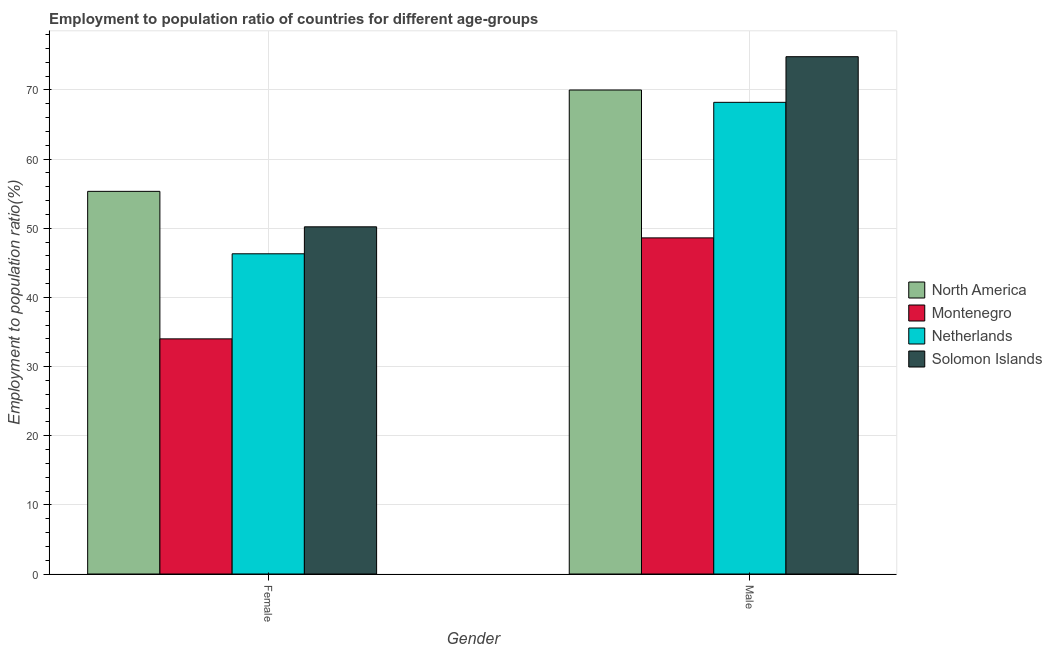How many groups of bars are there?
Your response must be concise. 2. Are the number of bars per tick equal to the number of legend labels?
Offer a very short reply. Yes. Are the number of bars on each tick of the X-axis equal?
Your response must be concise. Yes. How many bars are there on the 1st tick from the right?
Offer a very short reply. 4. What is the label of the 1st group of bars from the left?
Your response must be concise. Female. What is the employment to population ratio(female) in Netherlands?
Keep it short and to the point. 46.3. Across all countries, what is the maximum employment to population ratio(male)?
Offer a very short reply. 74.8. Across all countries, what is the minimum employment to population ratio(male)?
Your answer should be very brief. 48.6. In which country was the employment to population ratio(female) maximum?
Give a very brief answer. North America. In which country was the employment to population ratio(male) minimum?
Make the answer very short. Montenegro. What is the total employment to population ratio(female) in the graph?
Provide a short and direct response. 185.83. What is the difference between the employment to population ratio(female) in Montenegro and that in Netherlands?
Provide a succinct answer. -12.3. What is the difference between the employment to population ratio(male) in Netherlands and the employment to population ratio(female) in North America?
Ensure brevity in your answer.  12.87. What is the average employment to population ratio(female) per country?
Offer a terse response. 46.46. What is the difference between the employment to population ratio(male) and employment to population ratio(female) in Netherlands?
Keep it short and to the point. 21.9. In how many countries, is the employment to population ratio(male) greater than 30 %?
Provide a short and direct response. 4. What is the ratio of the employment to population ratio(female) in Montenegro to that in Solomon Islands?
Provide a succinct answer. 0.68. Is the employment to population ratio(female) in North America less than that in Montenegro?
Give a very brief answer. No. What does the 4th bar from the left in Female represents?
Ensure brevity in your answer.  Solomon Islands. What does the 1st bar from the right in Female represents?
Make the answer very short. Solomon Islands. Are all the bars in the graph horizontal?
Offer a very short reply. No. How many countries are there in the graph?
Your response must be concise. 4. What is the difference between two consecutive major ticks on the Y-axis?
Your answer should be compact. 10. How many legend labels are there?
Keep it short and to the point. 4. How are the legend labels stacked?
Your answer should be very brief. Vertical. What is the title of the graph?
Your response must be concise. Employment to population ratio of countries for different age-groups. What is the label or title of the Y-axis?
Offer a very short reply. Employment to population ratio(%). What is the Employment to population ratio(%) in North America in Female?
Give a very brief answer. 55.33. What is the Employment to population ratio(%) in Netherlands in Female?
Keep it short and to the point. 46.3. What is the Employment to population ratio(%) in Solomon Islands in Female?
Provide a succinct answer. 50.2. What is the Employment to population ratio(%) in North America in Male?
Provide a succinct answer. 69.98. What is the Employment to population ratio(%) of Montenegro in Male?
Give a very brief answer. 48.6. What is the Employment to population ratio(%) of Netherlands in Male?
Give a very brief answer. 68.2. What is the Employment to population ratio(%) of Solomon Islands in Male?
Give a very brief answer. 74.8. Across all Gender, what is the maximum Employment to population ratio(%) of North America?
Offer a very short reply. 69.98. Across all Gender, what is the maximum Employment to population ratio(%) in Montenegro?
Provide a succinct answer. 48.6. Across all Gender, what is the maximum Employment to population ratio(%) in Netherlands?
Your answer should be very brief. 68.2. Across all Gender, what is the maximum Employment to population ratio(%) of Solomon Islands?
Give a very brief answer. 74.8. Across all Gender, what is the minimum Employment to population ratio(%) of North America?
Your response must be concise. 55.33. Across all Gender, what is the minimum Employment to population ratio(%) of Netherlands?
Your response must be concise. 46.3. Across all Gender, what is the minimum Employment to population ratio(%) in Solomon Islands?
Your response must be concise. 50.2. What is the total Employment to population ratio(%) in North America in the graph?
Provide a succinct answer. 125.31. What is the total Employment to population ratio(%) of Montenegro in the graph?
Make the answer very short. 82.6. What is the total Employment to population ratio(%) of Netherlands in the graph?
Make the answer very short. 114.5. What is the total Employment to population ratio(%) in Solomon Islands in the graph?
Your answer should be compact. 125. What is the difference between the Employment to population ratio(%) of North America in Female and that in Male?
Your answer should be compact. -14.65. What is the difference between the Employment to population ratio(%) of Montenegro in Female and that in Male?
Your answer should be compact. -14.6. What is the difference between the Employment to population ratio(%) of Netherlands in Female and that in Male?
Provide a short and direct response. -21.9. What is the difference between the Employment to population ratio(%) in Solomon Islands in Female and that in Male?
Give a very brief answer. -24.6. What is the difference between the Employment to population ratio(%) in North America in Female and the Employment to population ratio(%) in Montenegro in Male?
Your response must be concise. 6.73. What is the difference between the Employment to population ratio(%) in North America in Female and the Employment to population ratio(%) in Netherlands in Male?
Offer a very short reply. -12.87. What is the difference between the Employment to population ratio(%) in North America in Female and the Employment to population ratio(%) in Solomon Islands in Male?
Your answer should be compact. -19.47. What is the difference between the Employment to population ratio(%) in Montenegro in Female and the Employment to population ratio(%) in Netherlands in Male?
Keep it short and to the point. -34.2. What is the difference between the Employment to population ratio(%) of Montenegro in Female and the Employment to population ratio(%) of Solomon Islands in Male?
Offer a very short reply. -40.8. What is the difference between the Employment to population ratio(%) in Netherlands in Female and the Employment to population ratio(%) in Solomon Islands in Male?
Give a very brief answer. -28.5. What is the average Employment to population ratio(%) in North America per Gender?
Offer a terse response. 62.66. What is the average Employment to population ratio(%) in Montenegro per Gender?
Ensure brevity in your answer.  41.3. What is the average Employment to population ratio(%) of Netherlands per Gender?
Give a very brief answer. 57.25. What is the average Employment to population ratio(%) of Solomon Islands per Gender?
Offer a very short reply. 62.5. What is the difference between the Employment to population ratio(%) of North America and Employment to population ratio(%) of Montenegro in Female?
Your answer should be very brief. 21.33. What is the difference between the Employment to population ratio(%) of North America and Employment to population ratio(%) of Netherlands in Female?
Provide a short and direct response. 9.03. What is the difference between the Employment to population ratio(%) of North America and Employment to population ratio(%) of Solomon Islands in Female?
Offer a very short reply. 5.13. What is the difference between the Employment to population ratio(%) in Montenegro and Employment to population ratio(%) in Solomon Islands in Female?
Make the answer very short. -16.2. What is the difference between the Employment to population ratio(%) of Netherlands and Employment to population ratio(%) of Solomon Islands in Female?
Your answer should be very brief. -3.9. What is the difference between the Employment to population ratio(%) of North America and Employment to population ratio(%) of Montenegro in Male?
Make the answer very short. 21.38. What is the difference between the Employment to population ratio(%) of North America and Employment to population ratio(%) of Netherlands in Male?
Offer a terse response. 1.78. What is the difference between the Employment to population ratio(%) in North America and Employment to population ratio(%) in Solomon Islands in Male?
Your answer should be very brief. -4.82. What is the difference between the Employment to population ratio(%) of Montenegro and Employment to population ratio(%) of Netherlands in Male?
Offer a very short reply. -19.6. What is the difference between the Employment to population ratio(%) of Montenegro and Employment to population ratio(%) of Solomon Islands in Male?
Your response must be concise. -26.2. What is the ratio of the Employment to population ratio(%) of North America in Female to that in Male?
Offer a very short reply. 0.79. What is the ratio of the Employment to population ratio(%) of Montenegro in Female to that in Male?
Give a very brief answer. 0.7. What is the ratio of the Employment to population ratio(%) in Netherlands in Female to that in Male?
Ensure brevity in your answer.  0.68. What is the ratio of the Employment to population ratio(%) of Solomon Islands in Female to that in Male?
Give a very brief answer. 0.67. What is the difference between the highest and the second highest Employment to population ratio(%) in North America?
Provide a succinct answer. 14.65. What is the difference between the highest and the second highest Employment to population ratio(%) in Netherlands?
Give a very brief answer. 21.9. What is the difference between the highest and the second highest Employment to population ratio(%) of Solomon Islands?
Keep it short and to the point. 24.6. What is the difference between the highest and the lowest Employment to population ratio(%) in North America?
Give a very brief answer. 14.65. What is the difference between the highest and the lowest Employment to population ratio(%) in Montenegro?
Ensure brevity in your answer.  14.6. What is the difference between the highest and the lowest Employment to population ratio(%) in Netherlands?
Offer a very short reply. 21.9. What is the difference between the highest and the lowest Employment to population ratio(%) in Solomon Islands?
Ensure brevity in your answer.  24.6. 